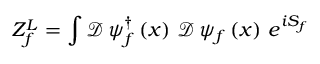<formula> <loc_0><loc_0><loc_500><loc_500>Z _ { f } ^ { L } = \int \mathcal { D } \, \psi _ { f } ^ { \dag } \left ( x \right ) \, \mathcal { D } \, \psi _ { f } \left ( x \right ) \, e ^ { i S _ { f } }</formula> 